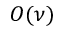<formula> <loc_0><loc_0><loc_500><loc_500>O ( \nu )</formula> 